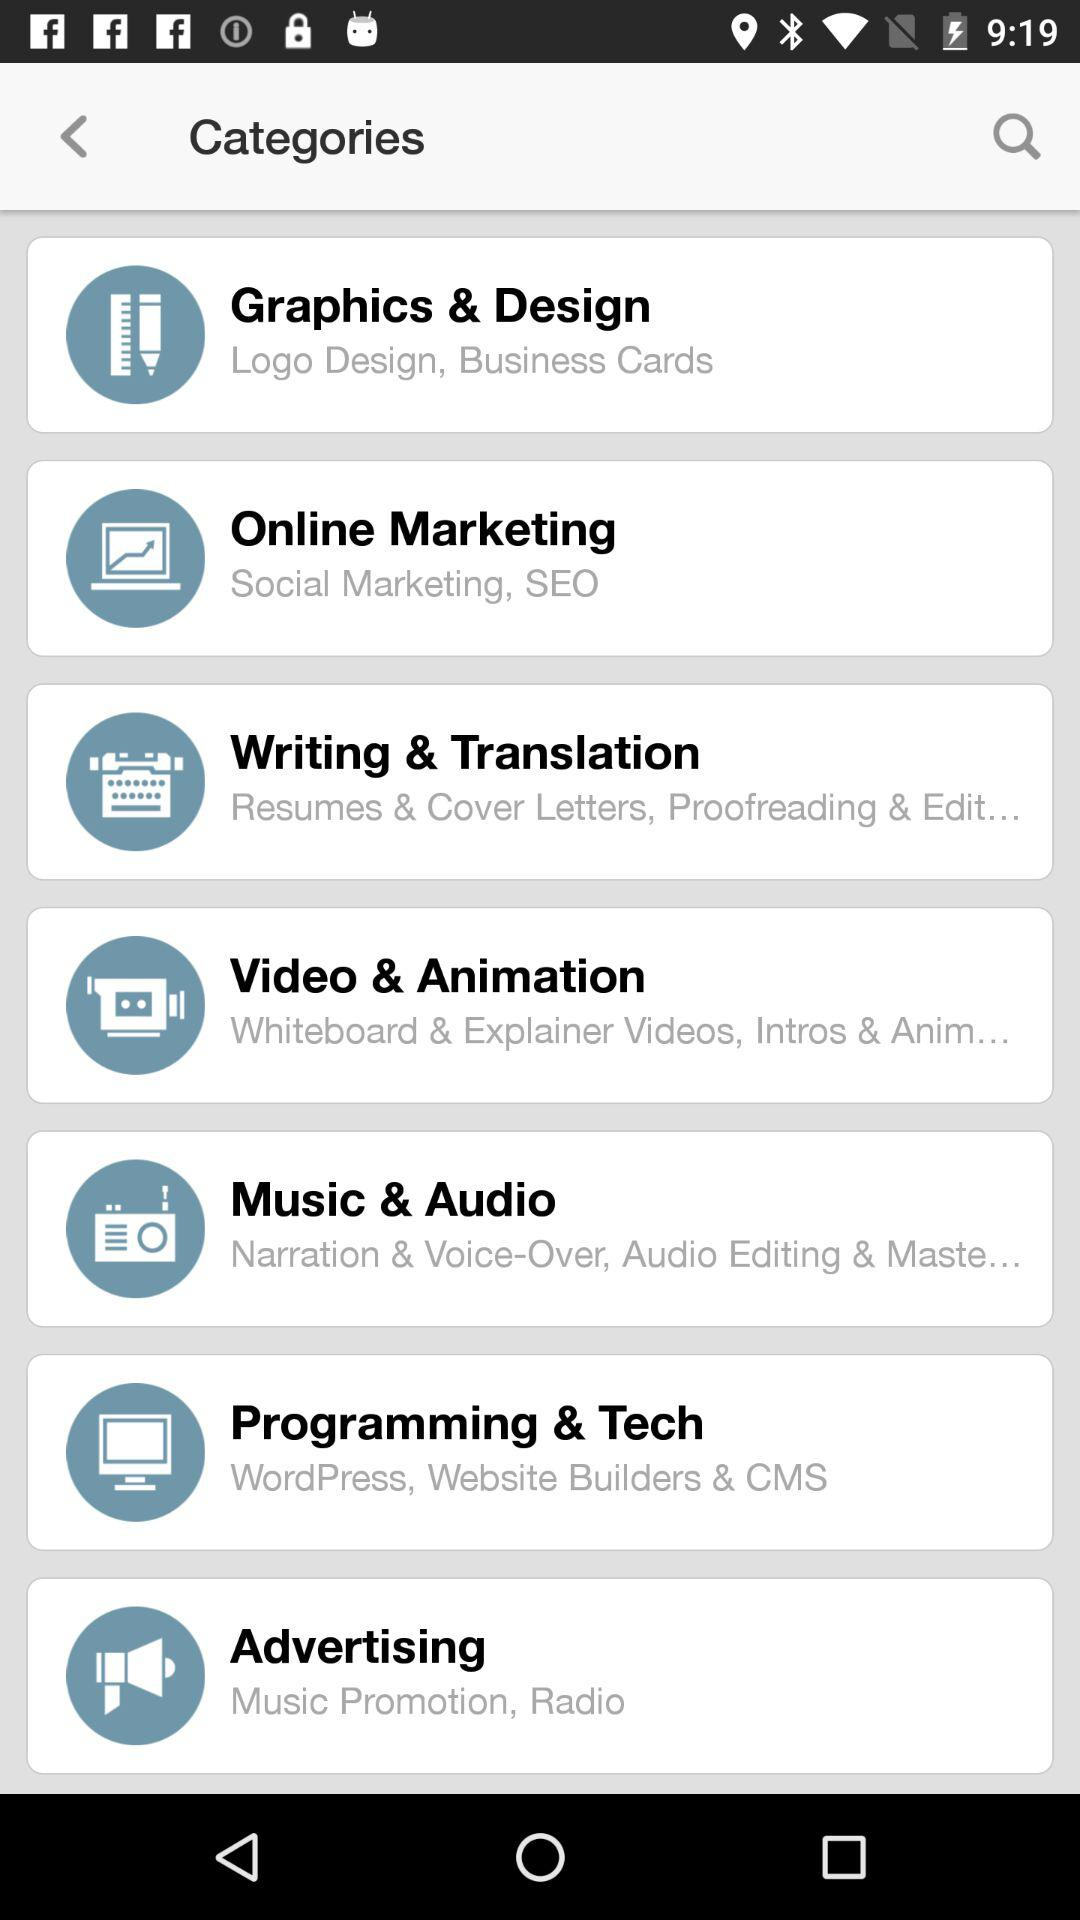What is included in the online marketing? The online marketing includes Social Marketing, SEO. 